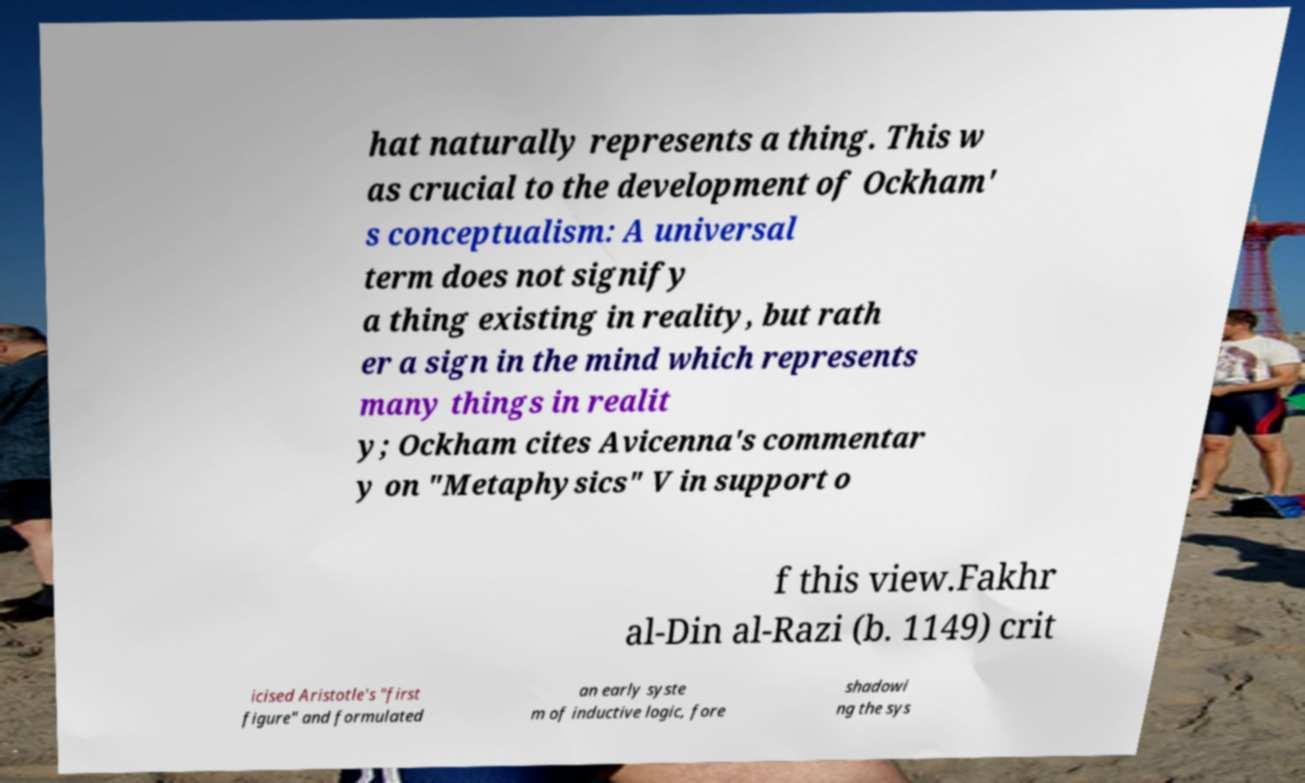There's text embedded in this image that I need extracted. Can you transcribe it verbatim? hat naturally represents a thing. This w as crucial to the development of Ockham' s conceptualism: A universal term does not signify a thing existing in reality, but rath er a sign in the mind which represents many things in realit y; Ockham cites Avicenna's commentar y on "Metaphysics" V in support o f this view.Fakhr al-Din al-Razi (b. 1149) crit icised Aristotle's "first figure" and formulated an early syste m of inductive logic, fore shadowi ng the sys 